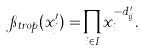Convert formula to latex. <formula><loc_0><loc_0><loc_500><loc_500>\pi _ { t r o p } ( x _ { j } ^ { \prime } ) = \prod _ { i \in I } x _ { i } ^ { - d ^ { \prime } _ { i j } } .</formula> 